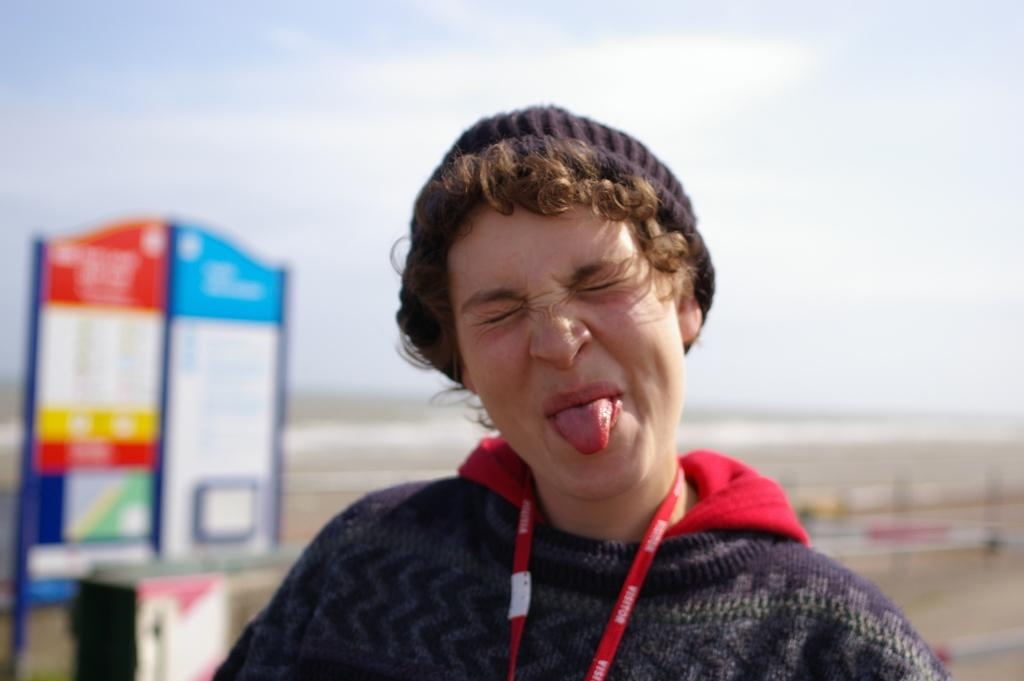Who is the main subject in the image? There is a woman in the image. What is the woman doing in the image? The woman is showing her tongue. What type of clothing is the woman wearing? The woman is wearing a sweater and a cap. What can be seen on the left side of the image? There is a board on the left side of the image. What is visible at the top of the image? The sky is visible at the top of the image. How many feet are visible in the image? There are no feet visible in the image; it only shows the woman's upper body. What type of bucket is present in the image? There is no bucket present in the image. 